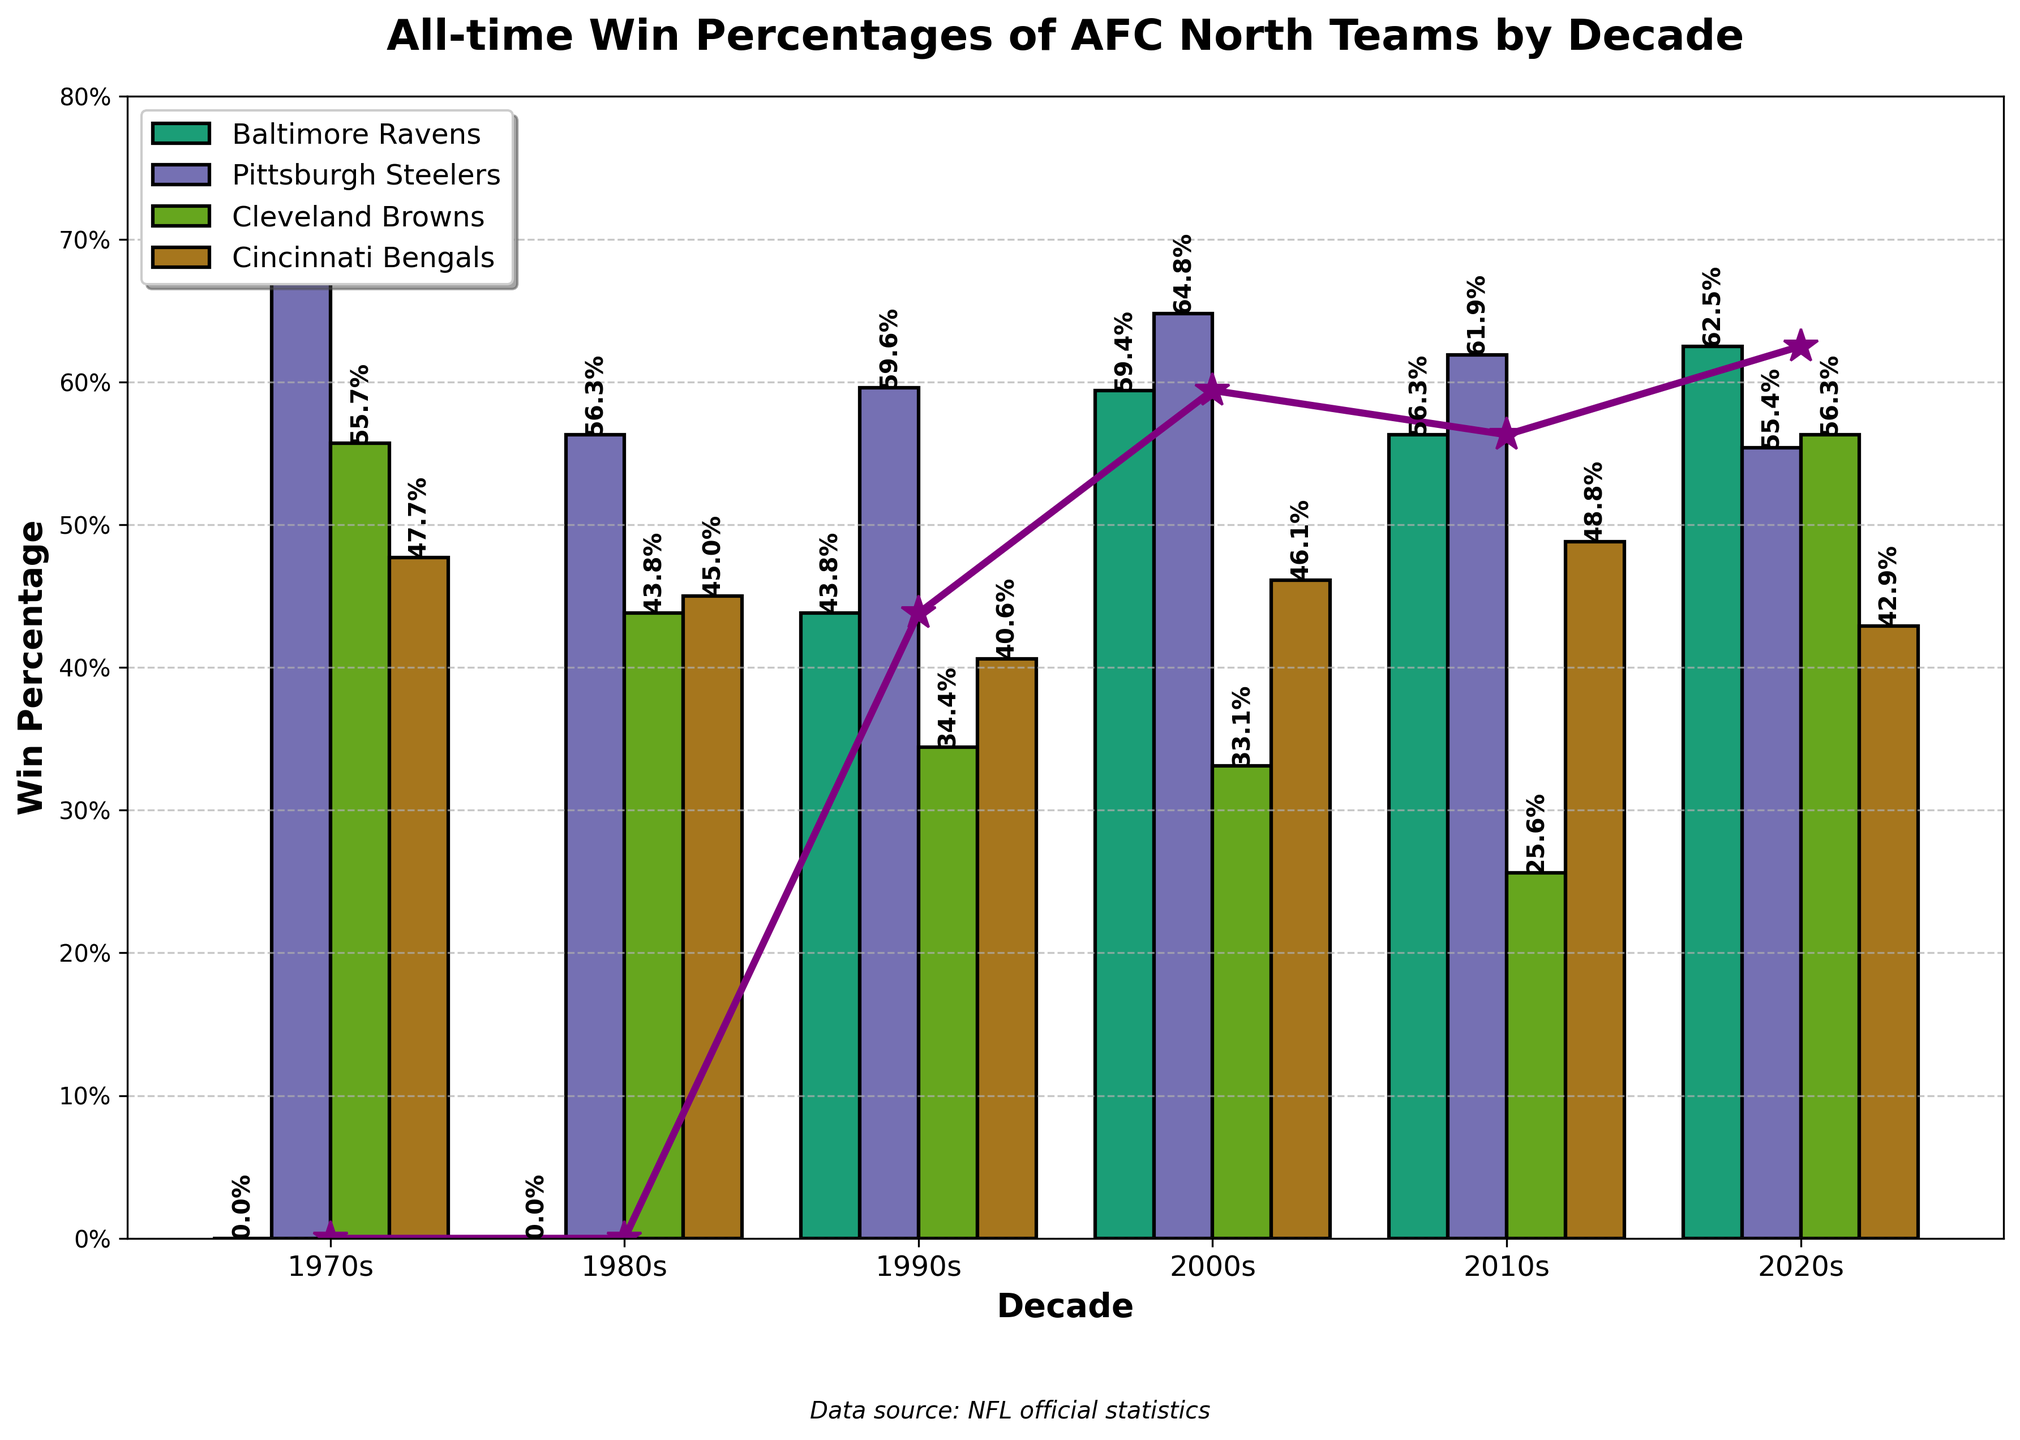How did the Baltimore Ravens' win percentage in the 2020s compare to their win percentage in the 2010s? Look at the heights of the bars for the Baltimore Ravens in the 2020s and 2010s. The win percentage in the 2020s is higher at 0.625 compared to 0.563 in the 2010s.
Answer: 0.625 vs. 0.563 Which decade had the highest win percentage for the Pittsburgh Steelers? Look at the heights of the bars for the Pittsburgh Steelers across all decades. The highest bar is in the 1970s with a win percentage of 0.692.
Answer: 1970s What is the average win percentage for the Cleveland Browns from the 2000s to the 2020s? Sum the win percentages for the Cleveland Browns in the 2000s (0.331), 2010s (0.256), and 2020s (0.563). The total is 0.331 + 0.256 + 0.563 = 1.15. Divide by 3 to get the average, which is 1.15 / 3 ≈ 0.383.
Answer: 0.383 In which decade did the Cincinnati Bengals have their lowest win percentage? Look at the heights of the bars for the Cincinnati Bengals across all decades. The lowest bar is in the 2020s with a win percentage of 0.429.
Answer: 2020s Which team had the most consistent win percentages across all decades? Compare the bars' consistency for each team over the decades. The Pittsburgh Steelers' bars are relatively consistent, showing the least deviation in heights.
Answer: Pittsburgh Steelers By how much did the Pittsburgh Steelers' win percentage drop from the 1970s to the 1980s? Subtract the Pittsburgh Steelers' win percentage in the 1980s (0.563) from their win percentage in the 1970s (0.692). The difference is 0.692 - 0.563 = 0.129.
Answer: 0.129 Which team had the highest win percentage in the 2000s, and what was it? Look at the heights of the bars in the 2000s for all teams. The Pittsburgh Steelers had the highest win percentage at 0.648 in the 2000s.
Answer: Pittsburgh Steelers, 0.648 How did the Cleveland Browns' win percentage in the 2010s compare to their win percentage in the 2020s? Look at the heights of the bars for the Cleveland Browns in the 2010s and 2020s. The win percentage in the 2020s is higher at 0.563 compared to 0.256 in the 2010s.
Answer: 0.563 vs. 0.256 